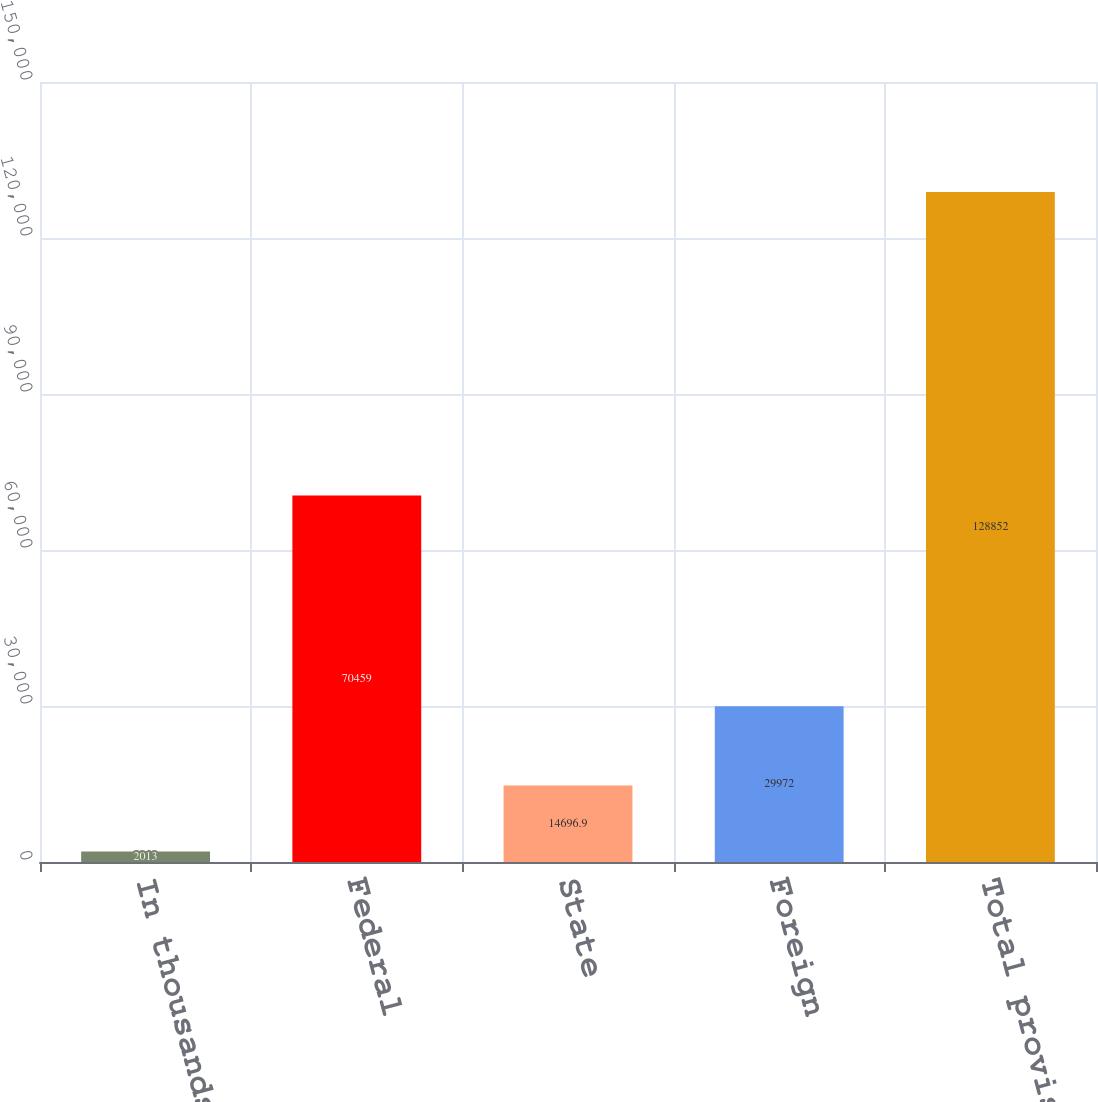<chart> <loc_0><loc_0><loc_500><loc_500><bar_chart><fcel>In thousands<fcel>Federal<fcel>State<fcel>Foreign<fcel>Total provision<nl><fcel>2013<fcel>70459<fcel>14696.9<fcel>29972<fcel>128852<nl></chart> 